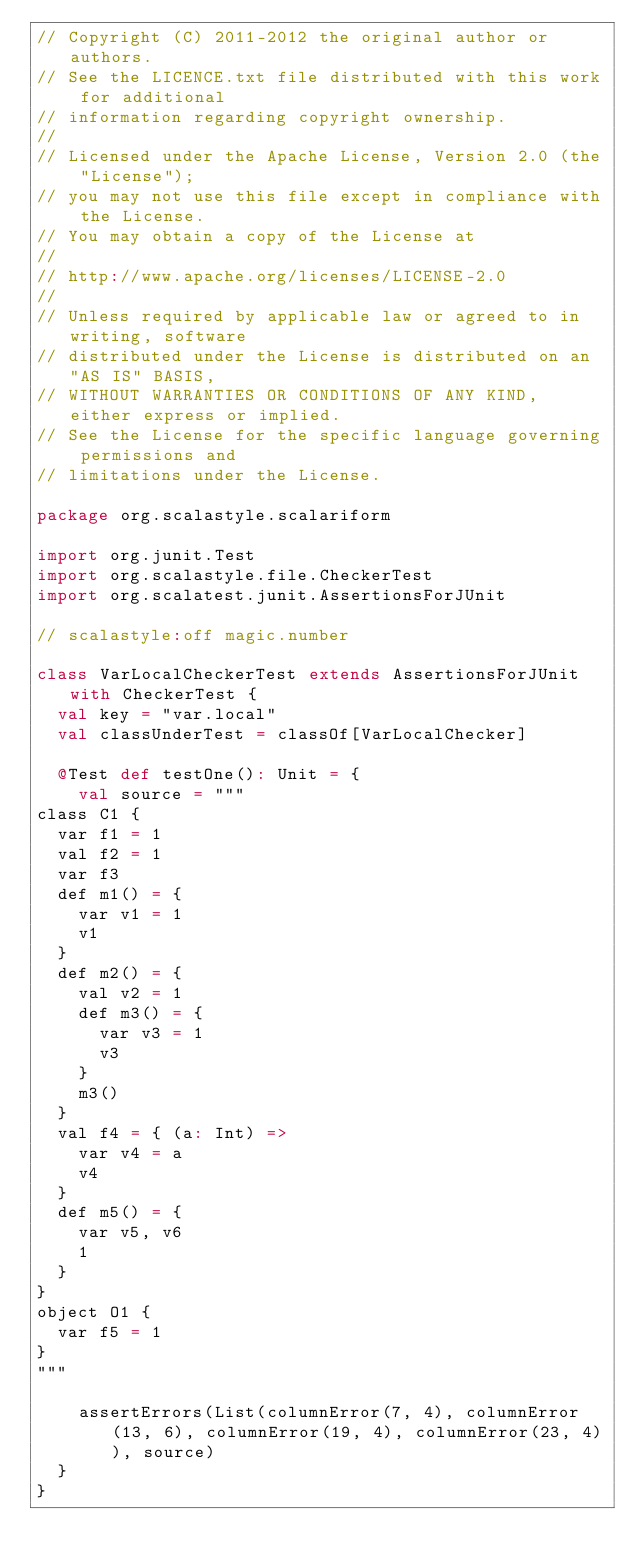Convert code to text. <code><loc_0><loc_0><loc_500><loc_500><_Scala_>// Copyright (C) 2011-2012 the original author or authors.
// See the LICENCE.txt file distributed with this work for additional
// information regarding copyright ownership.
//
// Licensed under the Apache License, Version 2.0 (the "License");
// you may not use this file except in compliance with the License.
// You may obtain a copy of the License at
//
// http://www.apache.org/licenses/LICENSE-2.0
//
// Unless required by applicable law or agreed to in writing, software
// distributed under the License is distributed on an "AS IS" BASIS,
// WITHOUT WARRANTIES OR CONDITIONS OF ANY KIND, either express or implied.
// See the License for the specific language governing permissions and
// limitations under the License.

package org.scalastyle.scalariform

import org.junit.Test
import org.scalastyle.file.CheckerTest
import org.scalatest.junit.AssertionsForJUnit

// scalastyle:off magic.number

class VarLocalCheckerTest extends AssertionsForJUnit with CheckerTest {
  val key = "var.local"
  val classUnderTest = classOf[VarLocalChecker]

  @Test def testOne(): Unit = {
    val source = """
class C1 {
  var f1 = 1
  val f2 = 1
  var f3
  def m1() = {
    var v1 = 1
    v1
  }
  def m2() = {
    val v2 = 1
    def m3() = {
      var v3 = 1
      v3
    }
    m3()
  }
  val f4 = { (a: Int) =>
    var v4 = a
    v4
  }
  def m5() = {
    var v5, v6
    1
  }
}
object O1 {
  var f5 = 1
}
"""

    assertErrors(List(columnError(7, 4), columnError(13, 6), columnError(19, 4), columnError(23, 4)), source)
  }
}
</code> 